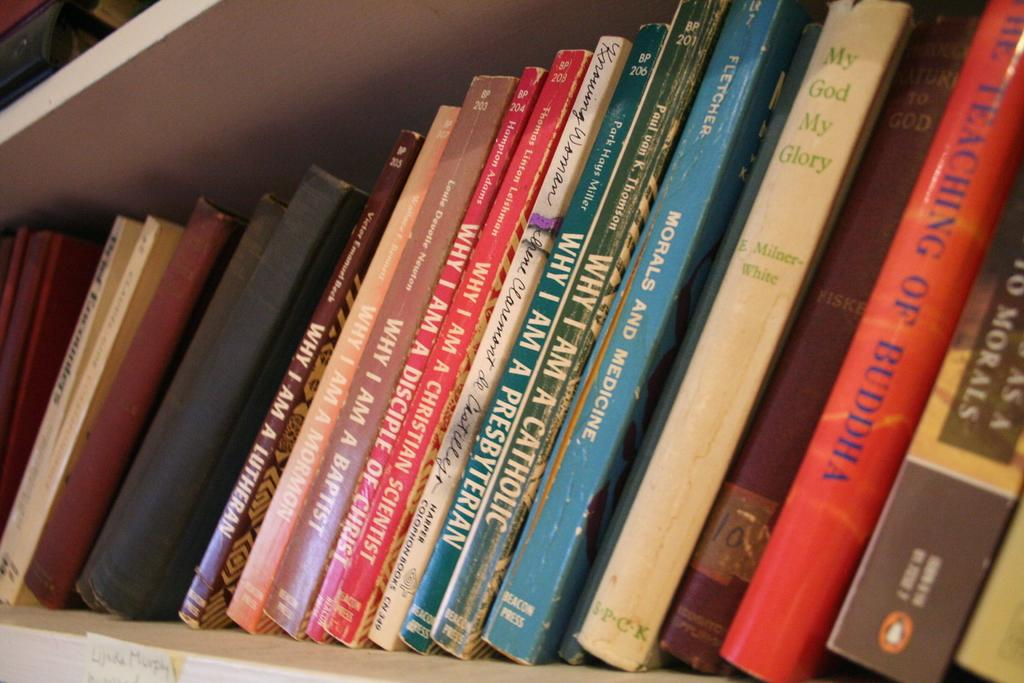<image>
Write a terse but informative summary of the picture. Books sit on a shelf including one called Why I'm A Catholic. 